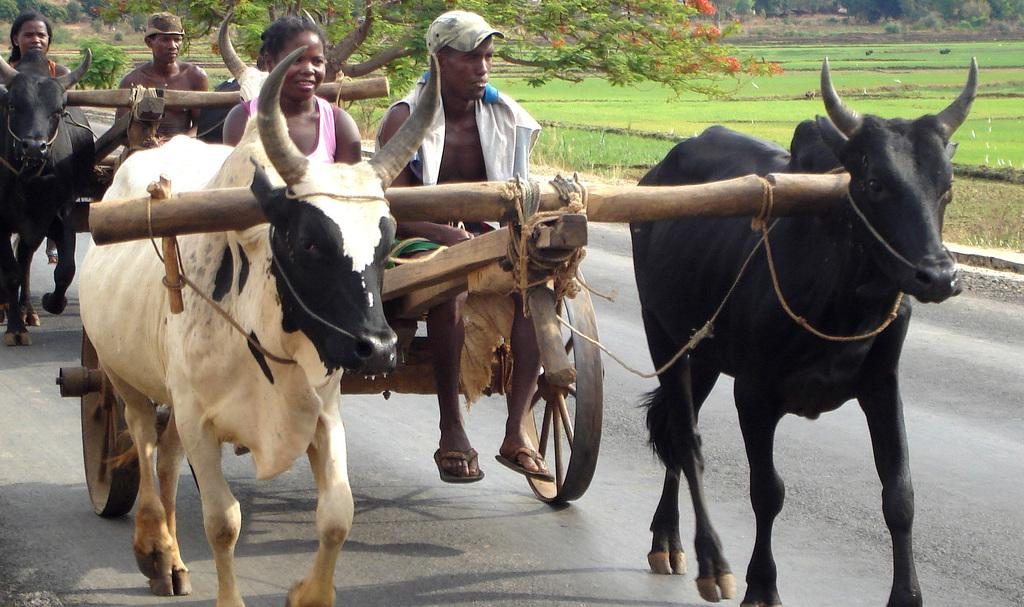What are the persons in the image riding? The persons in the image are riding bullock carts. Where are the bullock carts located? The bullock carts are on a road. What type of vegetation can be seen in the background of the image? There is grass on the ground in the background of the image, and there are also trees. What type of crate is being used to transport the bullocks in the image? There is no crate present in the image; the bullocks are pulling the carts directly. 